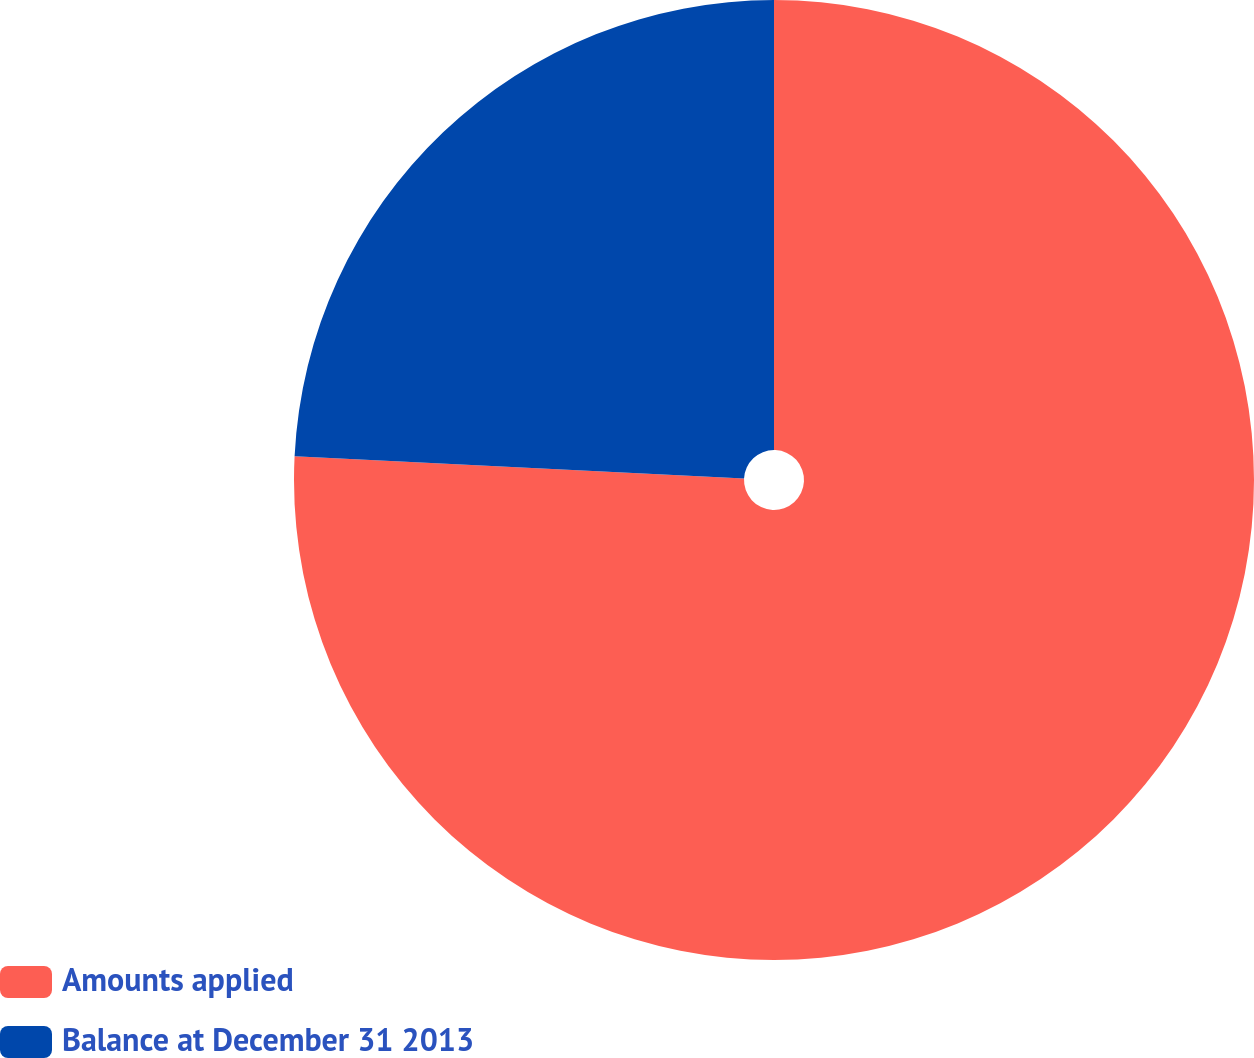Convert chart. <chart><loc_0><loc_0><loc_500><loc_500><pie_chart><fcel>Amounts applied<fcel>Balance at December 31 2013<nl><fcel>75.79%<fcel>24.21%<nl></chart> 